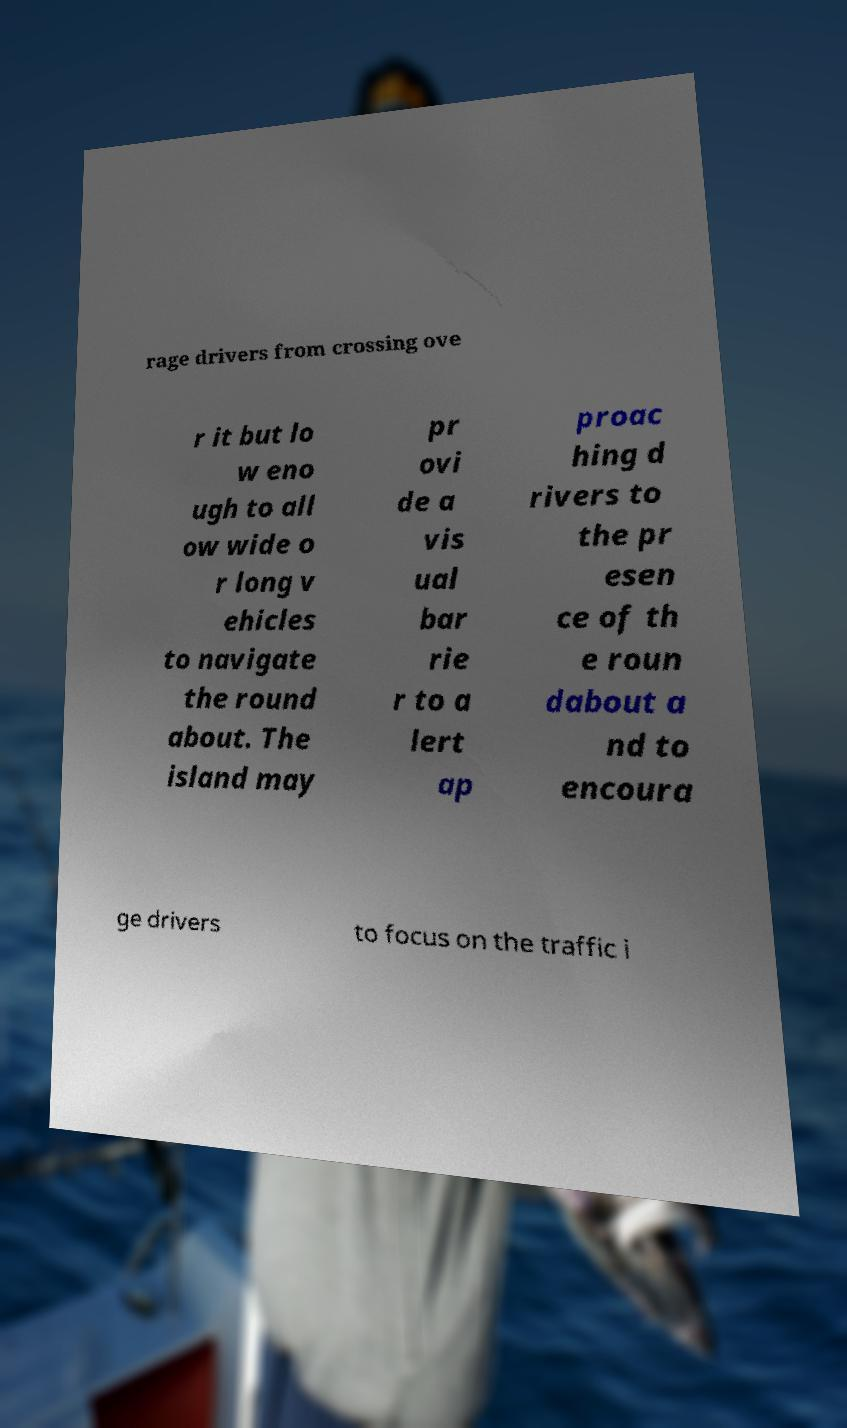Could you extract and type out the text from this image? rage drivers from crossing ove r it but lo w eno ugh to all ow wide o r long v ehicles to navigate the round about. The island may pr ovi de a vis ual bar rie r to a lert ap proac hing d rivers to the pr esen ce of th e roun dabout a nd to encoura ge drivers to focus on the traffic i 